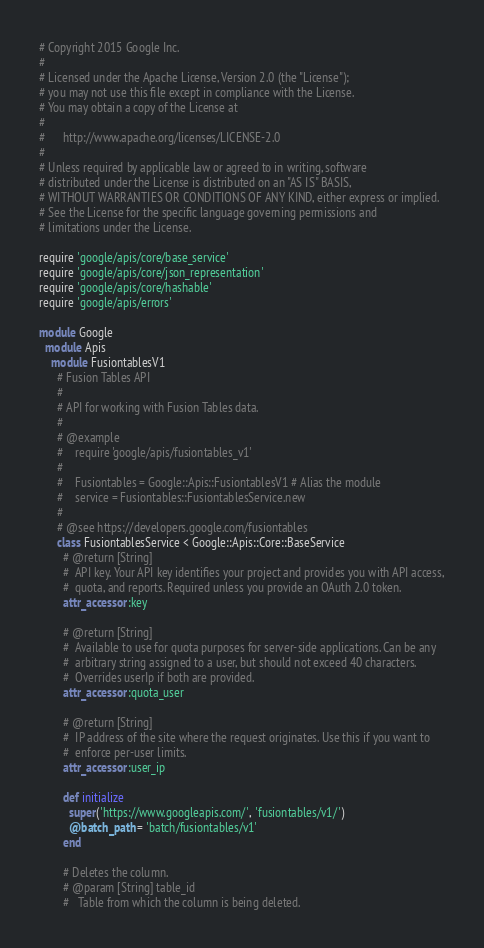<code> <loc_0><loc_0><loc_500><loc_500><_Ruby_># Copyright 2015 Google Inc.
#
# Licensed under the Apache License, Version 2.0 (the "License");
# you may not use this file except in compliance with the License.
# You may obtain a copy of the License at
#
#      http://www.apache.org/licenses/LICENSE-2.0
#
# Unless required by applicable law or agreed to in writing, software
# distributed under the License is distributed on an "AS IS" BASIS,
# WITHOUT WARRANTIES OR CONDITIONS OF ANY KIND, either express or implied.
# See the License for the specific language governing permissions and
# limitations under the License.

require 'google/apis/core/base_service'
require 'google/apis/core/json_representation'
require 'google/apis/core/hashable'
require 'google/apis/errors'

module Google
  module Apis
    module FusiontablesV1
      # Fusion Tables API
      #
      # API for working with Fusion Tables data.
      #
      # @example
      #    require 'google/apis/fusiontables_v1'
      #
      #    Fusiontables = Google::Apis::FusiontablesV1 # Alias the module
      #    service = Fusiontables::FusiontablesService.new
      #
      # @see https://developers.google.com/fusiontables
      class FusiontablesService < Google::Apis::Core::BaseService
        # @return [String]
        #  API key. Your API key identifies your project and provides you with API access,
        #  quota, and reports. Required unless you provide an OAuth 2.0 token.
        attr_accessor :key

        # @return [String]
        #  Available to use for quota purposes for server-side applications. Can be any
        #  arbitrary string assigned to a user, but should not exceed 40 characters.
        #  Overrides userIp if both are provided.
        attr_accessor :quota_user

        # @return [String]
        #  IP address of the site where the request originates. Use this if you want to
        #  enforce per-user limits.
        attr_accessor :user_ip

        def initialize
          super('https://www.googleapis.com/', 'fusiontables/v1/')
          @batch_path = 'batch/fusiontables/v1'
        end
        
        # Deletes the column.
        # @param [String] table_id
        #   Table from which the column is being deleted.</code> 